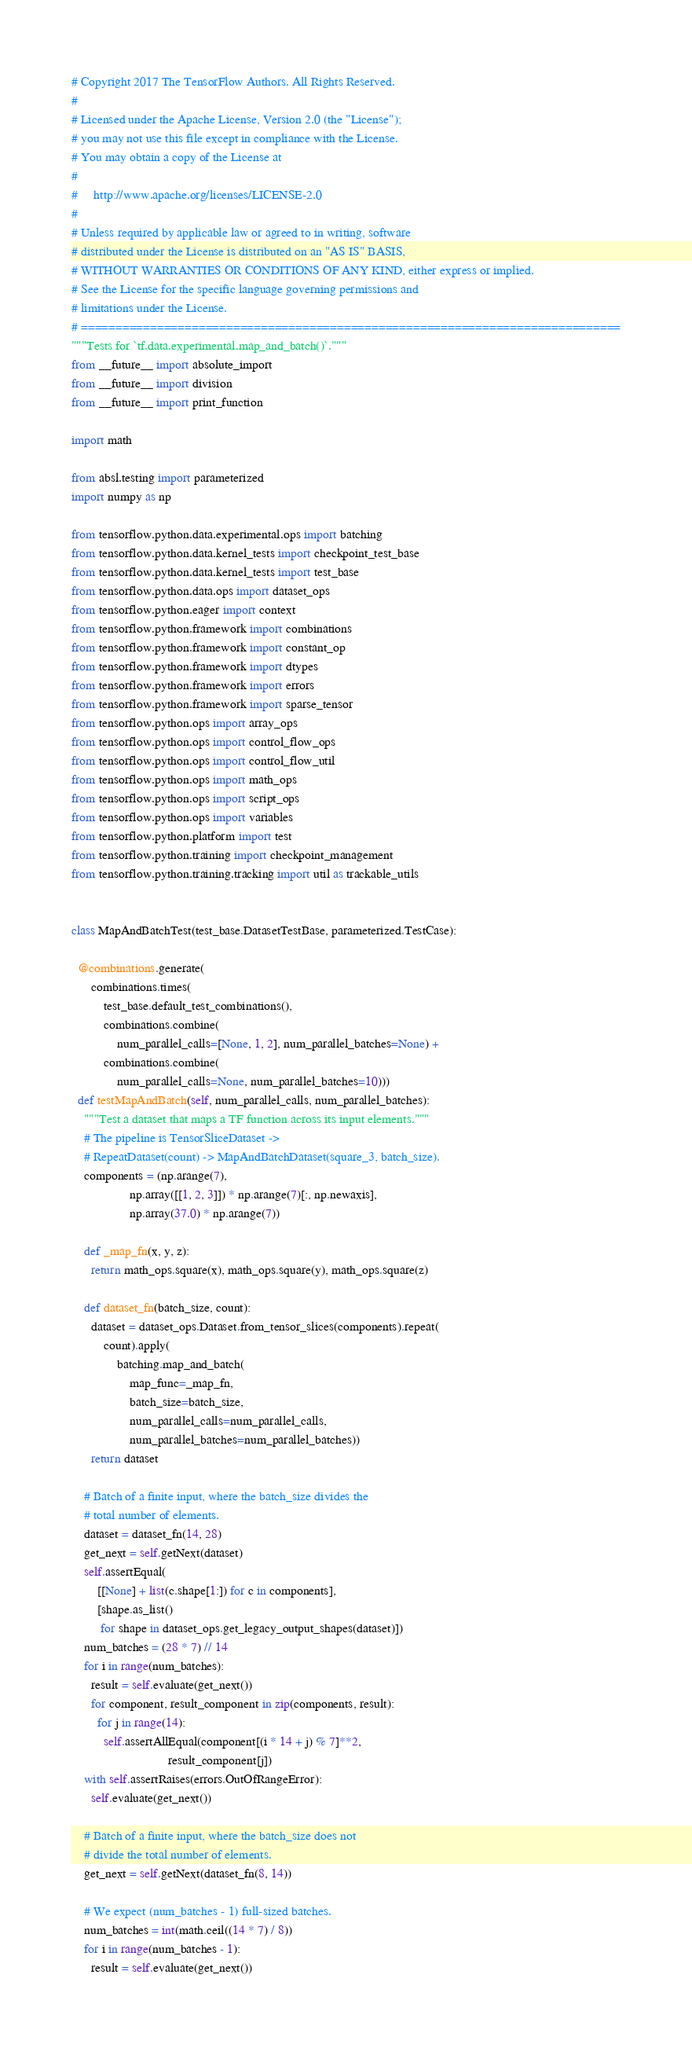Convert code to text. <code><loc_0><loc_0><loc_500><loc_500><_Python_># Copyright 2017 The TensorFlow Authors. All Rights Reserved.
#
# Licensed under the Apache License, Version 2.0 (the "License");
# you may not use this file except in compliance with the License.
# You may obtain a copy of the License at
#
#     http://www.apache.org/licenses/LICENSE-2.0
#
# Unless required by applicable law or agreed to in writing, software
# distributed under the License is distributed on an "AS IS" BASIS,
# WITHOUT WARRANTIES OR CONDITIONS OF ANY KIND, either express or implied.
# See the License for the specific language governing permissions and
# limitations under the License.
# ==============================================================================
"""Tests for `tf.data.experimental.map_and_batch()`."""
from __future__ import absolute_import
from __future__ import division
from __future__ import print_function

import math

from absl.testing import parameterized
import numpy as np

from tensorflow.python.data.experimental.ops import batching
from tensorflow.python.data.kernel_tests import checkpoint_test_base
from tensorflow.python.data.kernel_tests import test_base
from tensorflow.python.data.ops import dataset_ops
from tensorflow.python.eager import context
from tensorflow.python.framework import combinations
from tensorflow.python.framework import constant_op
from tensorflow.python.framework import dtypes
from tensorflow.python.framework import errors
from tensorflow.python.framework import sparse_tensor
from tensorflow.python.ops import array_ops
from tensorflow.python.ops import control_flow_ops
from tensorflow.python.ops import control_flow_util
from tensorflow.python.ops import math_ops
from tensorflow.python.ops import script_ops
from tensorflow.python.ops import variables
from tensorflow.python.platform import test
from tensorflow.python.training import checkpoint_management
from tensorflow.python.training.tracking import util as trackable_utils


class MapAndBatchTest(test_base.DatasetTestBase, parameterized.TestCase):

  @combinations.generate(
      combinations.times(
          test_base.default_test_combinations(),
          combinations.combine(
              num_parallel_calls=[None, 1, 2], num_parallel_batches=None) +
          combinations.combine(
              num_parallel_calls=None, num_parallel_batches=10)))
  def testMapAndBatch(self, num_parallel_calls, num_parallel_batches):
    """Test a dataset that maps a TF function across its input elements."""
    # The pipeline is TensorSliceDataset ->
    # RepeatDataset(count) -> MapAndBatchDataset(square_3, batch_size).
    components = (np.arange(7),
                  np.array([[1, 2, 3]]) * np.arange(7)[:, np.newaxis],
                  np.array(37.0) * np.arange(7))

    def _map_fn(x, y, z):
      return math_ops.square(x), math_ops.square(y), math_ops.square(z)

    def dataset_fn(batch_size, count):
      dataset = dataset_ops.Dataset.from_tensor_slices(components).repeat(
          count).apply(
              batching.map_and_batch(
                  map_func=_map_fn,
                  batch_size=batch_size,
                  num_parallel_calls=num_parallel_calls,
                  num_parallel_batches=num_parallel_batches))
      return dataset

    # Batch of a finite input, where the batch_size divides the
    # total number of elements.
    dataset = dataset_fn(14, 28)
    get_next = self.getNext(dataset)
    self.assertEqual(
        [[None] + list(c.shape[1:]) for c in components],
        [shape.as_list()
         for shape in dataset_ops.get_legacy_output_shapes(dataset)])
    num_batches = (28 * 7) // 14
    for i in range(num_batches):
      result = self.evaluate(get_next())
      for component, result_component in zip(components, result):
        for j in range(14):
          self.assertAllEqual(component[(i * 14 + j) % 7]**2,
                              result_component[j])
    with self.assertRaises(errors.OutOfRangeError):
      self.evaluate(get_next())

    # Batch of a finite input, where the batch_size does not
    # divide the total number of elements.
    get_next = self.getNext(dataset_fn(8, 14))

    # We expect (num_batches - 1) full-sized batches.
    num_batches = int(math.ceil((14 * 7) / 8))
    for i in range(num_batches - 1):
      result = self.evaluate(get_next())</code> 